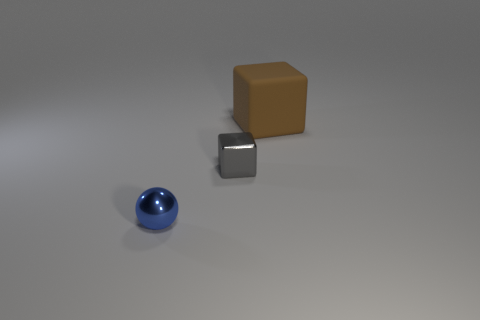There is a block that is left of the big rubber thing; how many small objects are to the left of it?
Make the answer very short. 1. How many other objects are the same shape as the tiny gray object?
Provide a succinct answer. 1. What number of small gray things are there?
Make the answer very short. 1. There is a small metallic thing behind the tiny metallic ball; what is its color?
Make the answer very short. Gray. The metallic thing that is left of the cube on the left side of the big brown cube is what color?
Keep it short and to the point. Blue. There is a shiny object that is the same size as the metal block; what color is it?
Keep it short and to the point. Blue. What number of cubes are behind the gray cube and in front of the matte cube?
Ensure brevity in your answer.  0. There is a thing that is both right of the metallic ball and on the left side of the large block; what is its material?
Your answer should be very brief. Metal. Is the number of brown rubber blocks that are on the right side of the metal ball less than the number of small gray cubes behind the brown rubber block?
Ensure brevity in your answer.  No. The ball that is the same material as the gray object is what size?
Make the answer very short. Small. 